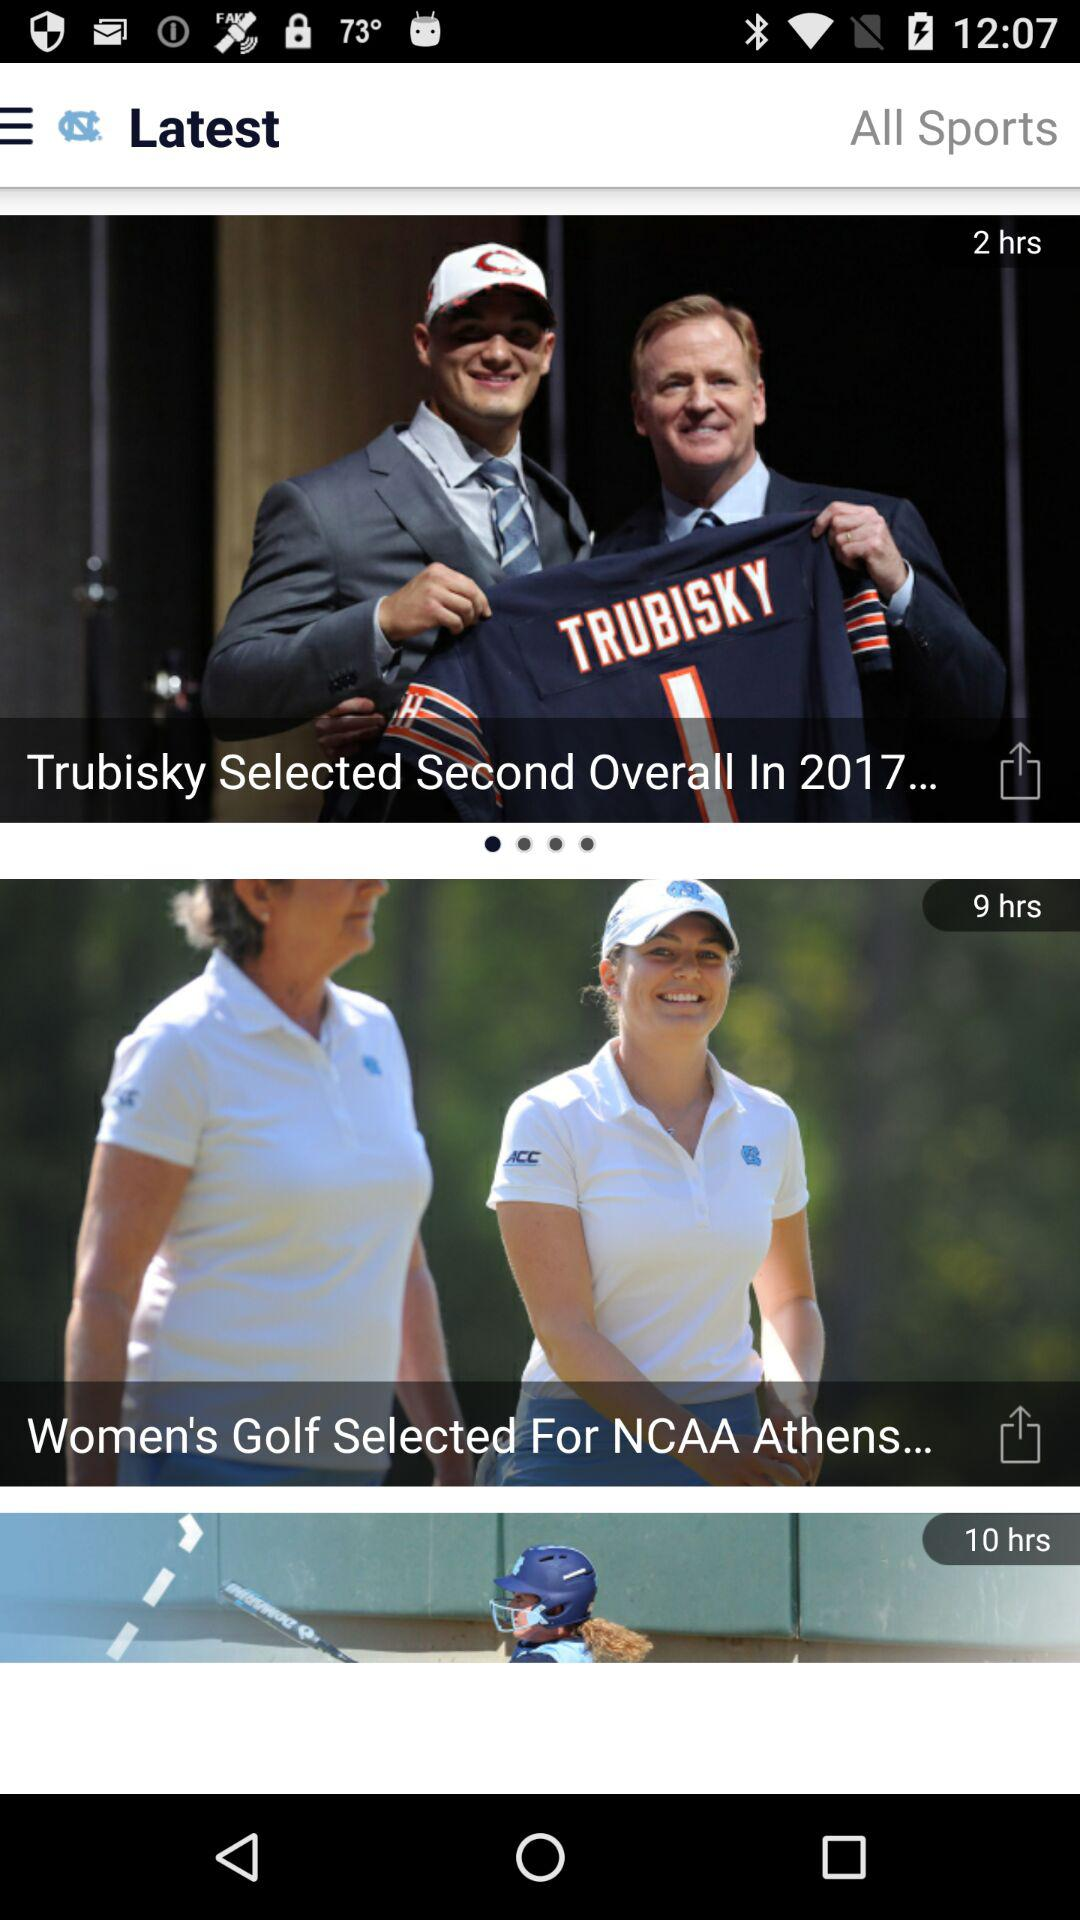How many hours ago was "Women's Golf Selected For NCAA Athens..." posted? It was posted 9 hours ago. 